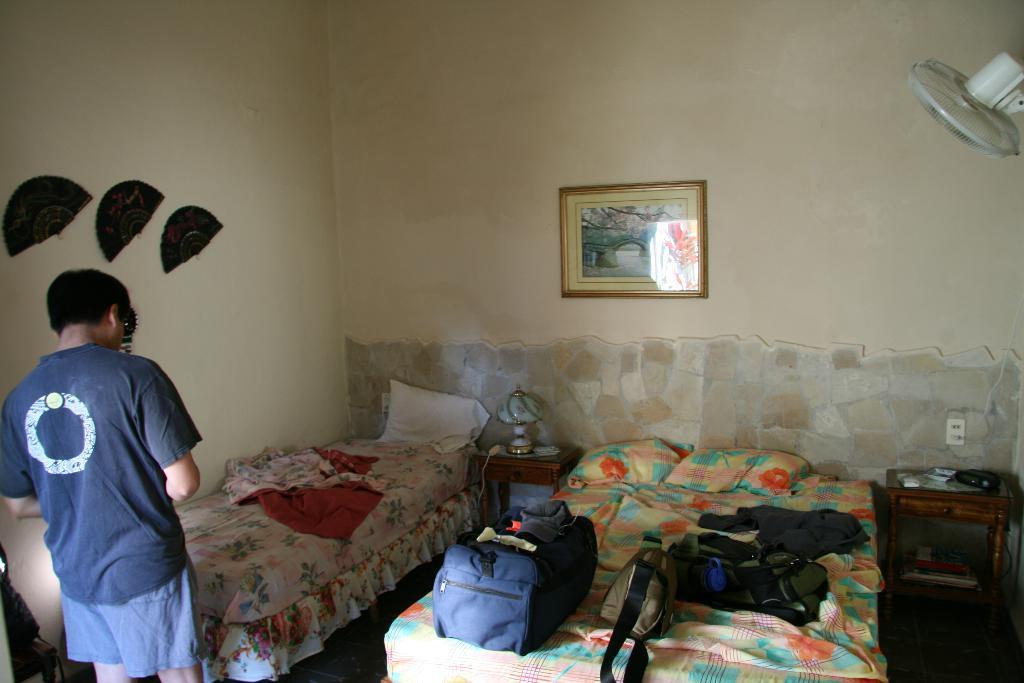Can you describe this image briefly? There is a photo frame over a wall. We can see one man standing near to the bed cots. There is a table lamp on the table. We can see bags and clothes on the beds. This is a floor. At the right side of the picture we can see a fan. 